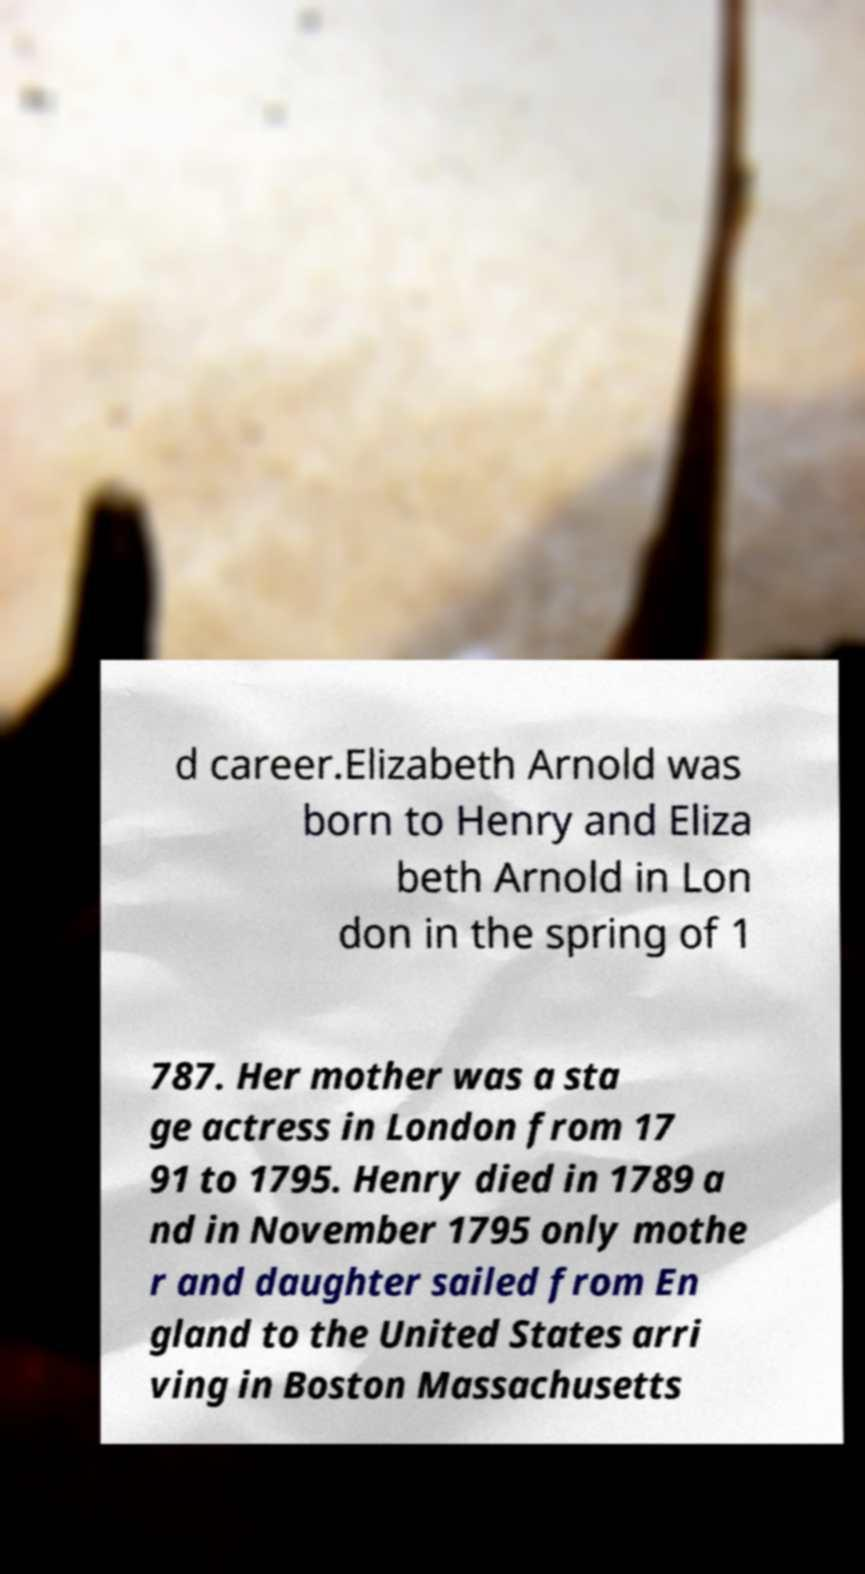Could you assist in decoding the text presented in this image and type it out clearly? d career.Elizabeth Arnold was born to Henry and Eliza beth Arnold in Lon don in the spring of 1 787. Her mother was a sta ge actress in London from 17 91 to 1795. Henry died in 1789 a nd in November 1795 only mothe r and daughter sailed from En gland to the United States arri ving in Boston Massachusetts 